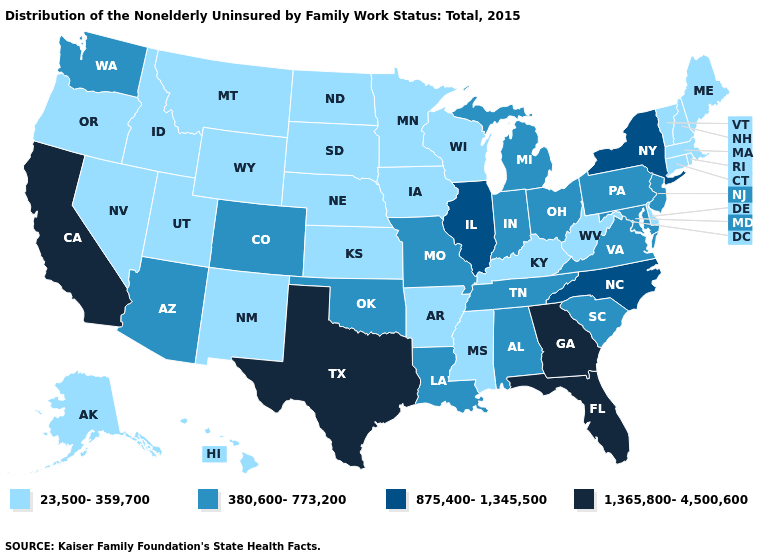Name the states that have a value in the range 380,600-773,200?
Short answer required. Alabama, Arizona, Colorado, Indiana, Louisiana, Maryland, Michigan, Missouri, New Jersey, Ohio, Oklahoma, Pennsylvania, South Carolina, Tennessee, Virginia, Washington. Does the first symbol in the legend represent the smallest category?
Short answer required. Yes. Among the states that border Pennsylvania , does New Jersey have the lowest value?
Be succinct. No. Which states have the lowest value in the USA?
Quick response, please. Alaska, Arkansas, Connecticut, Delaware, Hawaii, Idaho, Iowa, Kansas, Kentucky, Maine, Massachusetts, Minnesota, Mississippi, Montana, Nebraska, Nevada, New Hampshire, New Mexico, North Dakota, Oregon, Rhode Island, South Dakota, Utah, Vermont, West Virginia, Wisconsin, Wyoming. Is the legend a continuous bar?
Quick response, please. No. Which states have the highest value in the USA?
Short answer required. California, Florida, Georgia, Texas. What is the value of Montana?
Keep it brief. 23,500-359,700. What is the value of Kansas?
Answer briefly. 23,500-359,700. Name the states that have a value in the range 875,400-1,345,500?
Give a very brief answer. Illinois, New York, North Carolina. Does the first symbol in the legend represent the smallest category?
Concise answer only. Yes. Does the map have missing data?
Give a very brief answer. No. Among the states that border Kentucky , does West Virginia have the lowest value?
Keep it brief. Yes. What is the value of Michigan?
Be succinct. 380,600-773,200. What is the value of South Carolina?
Write a very short answer. 380,600-773,200. Name the states that have a value in the range 380,600-773,200?
Keep it brief. Alabama, Arizona, Colorado, Indiana, Louisiana, Maryland, Michigan, Missouri, New Jersey, Ohio, Oklahoma, Pennsylvania, South Carolina, Tennessee, Virginia, Washington. 